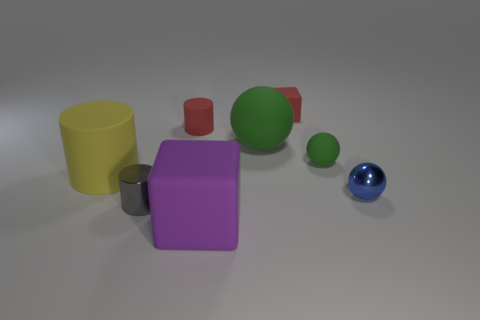There is a red matte cube; is its size the same as the shiny object that is on the right side of the big purple matte block?
Your answer should be compact. Yes. How many other things are there of the same color as the tiny metallic ball?
Give a very brief answer. 0. There is a small block; are there any small objects behind it?
Offer a very short reply. No. What number of things are yellow shiny balls or large rubber objects to the right of the small rubber cylinder?
Offer a terse response. 2. There is a green sphere that is in front of the big ball; is there a tiny green matte thing that is behind it?
Give a very brief answer. No. What is the shape of the matte object that is in front of the tiny shiny thing that is on the left side of the large matte object in front of the big cylinder?
Provide a succinct answer. Cube. There is a large thing that is both in front of the big green rubber object and right of the gray cylinder; what color is it?
Your answer should be very brief. Purple. What is the shape of the metal thing left of the big green rubber object?
Offer a terse response. Cylinder. The large purple thing that is the same material as the big sphere is what shape?
Your answer should be very brief. Cube. How many metal objects are small spheres or tiny gray cylinders?
Ensure brevity in your answer.  2. 